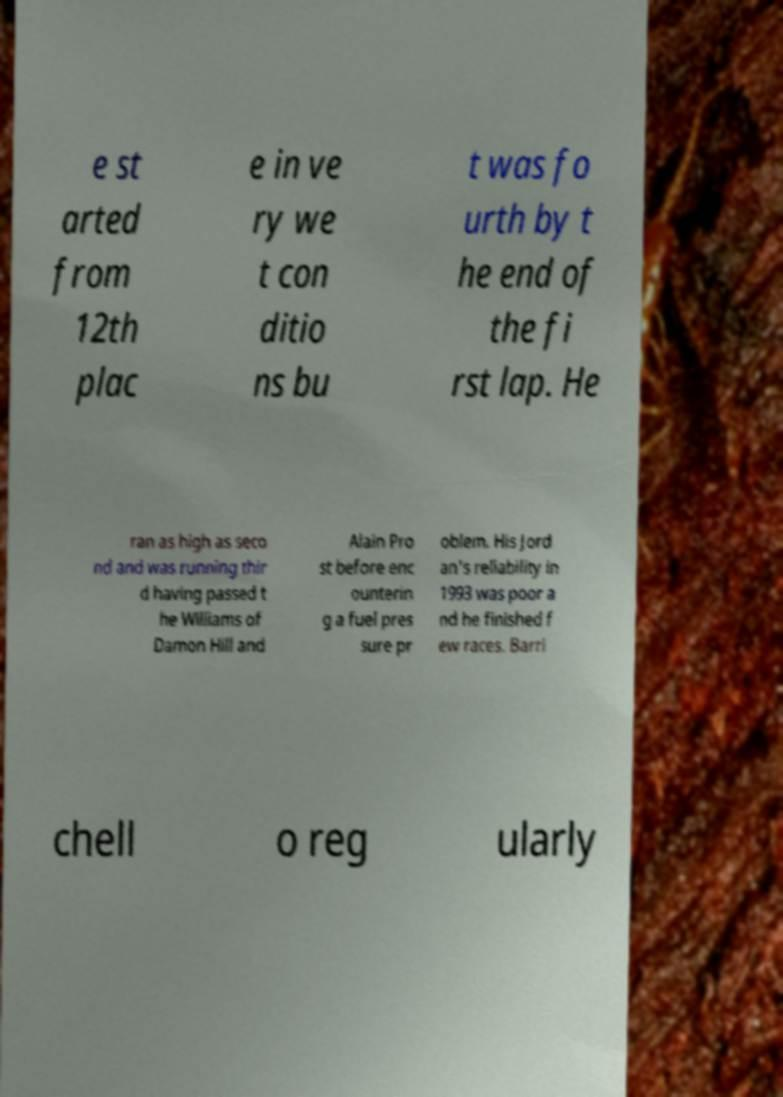Can you accurately transcribe the text from the provided image for me? e st arted from 12th plac e in ve ry we t con ditio ns bu t was fo urth by t he end of the fi rst lap. He ran as high as seco nd and was running thir d having passed t he Williams of Damon Hill and Alain Pro st before enc ounterin g a fuel pres sure pr oblem. His Jord an's reliability in 1993 was poor a nd he finished f ew races. Barri chell o reg ularly 